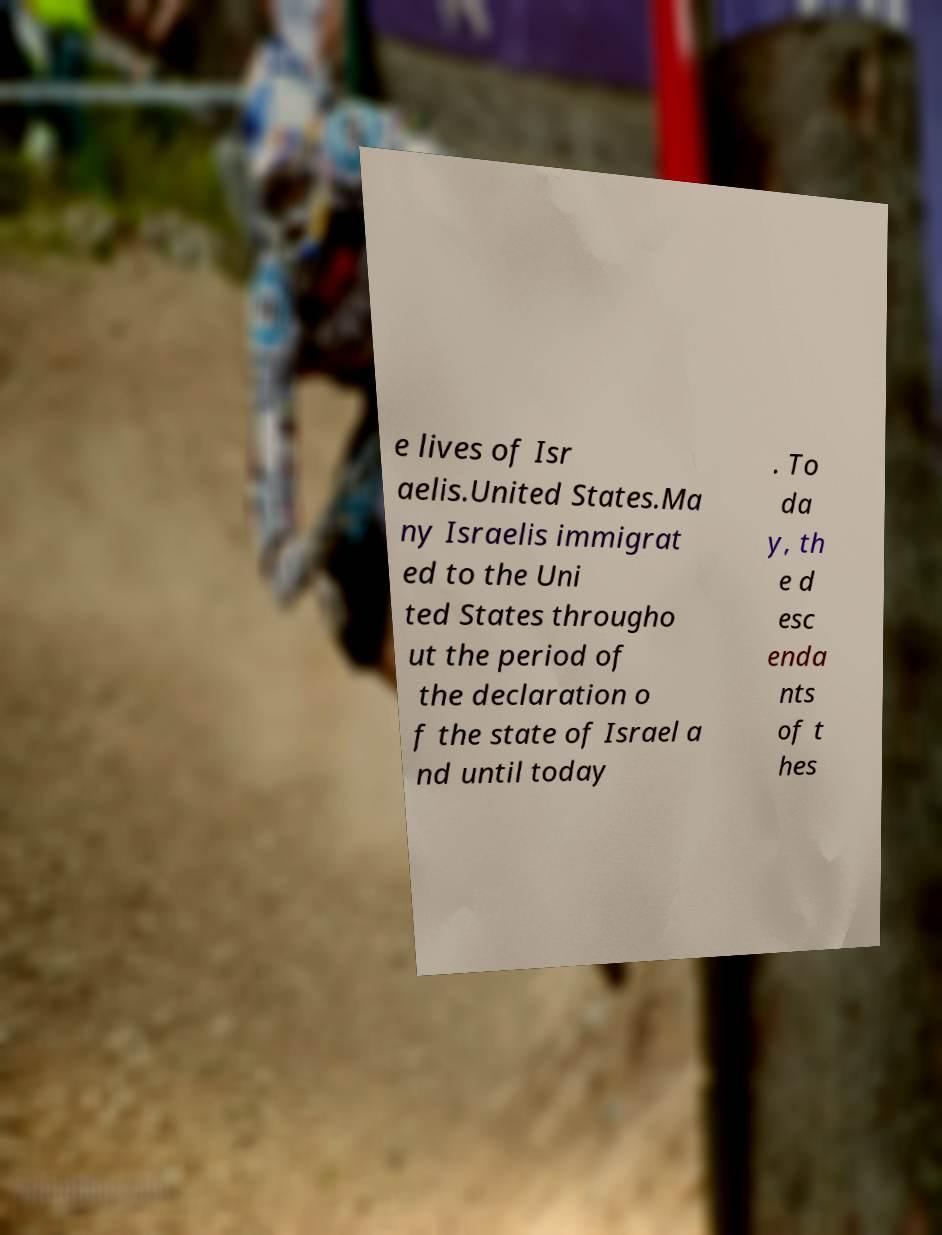I need the written content from this picture converted into text. Can you do that? e lives of Isr aelis.United States.Ma ny Israelis immigrat ed to the Uni ted States througho ut the period of the declaration o f the state of Israel a nd until today . To da y, th e d esc enda nts of t hes 